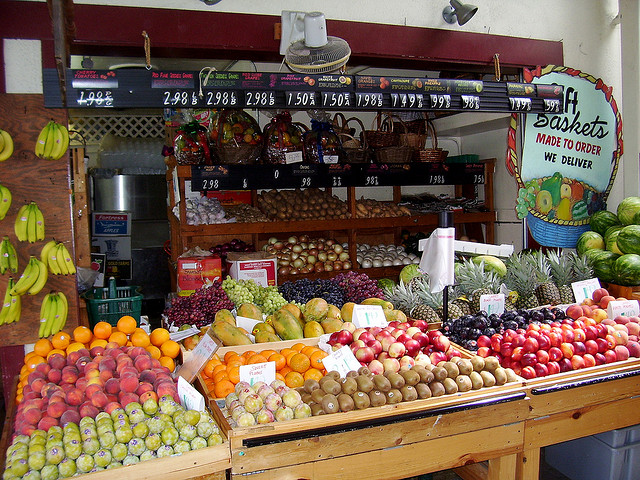Identify and read out the text in this image. MADE ORDER WE DELIVER Baskets 298 98 981 198 151 ft, 59 1495 985 99 1493 198 1.50EA 1.50 EA 2.98 LB 298 298 